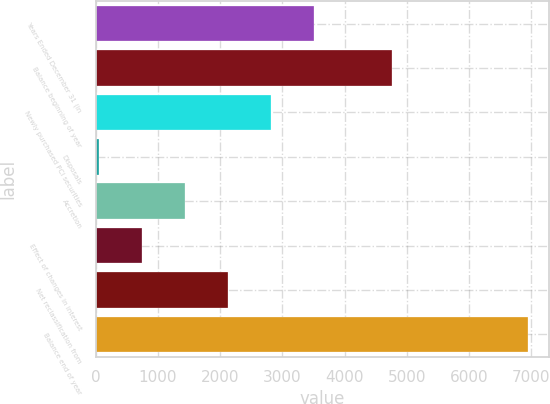Convert chart to OTSL. <chart><loc_0><loc_0><loc_500><loc_500><bar_chart><fcel>Years Ended December 31 (in<fcel>Balance beginning of year<fcel>Newly purchased PCI securities<fcel>Disposals<fcel>Accretion<fcel>Effect of changes in interest<fcel>Net reclassification from<fcel>Balance end of year<nl><fcel>3500<fcel>4766<fcel>2812<fcel>60<fcel>1436<fcel>748<fcel>2124<fcel>6940<nl></chart> 